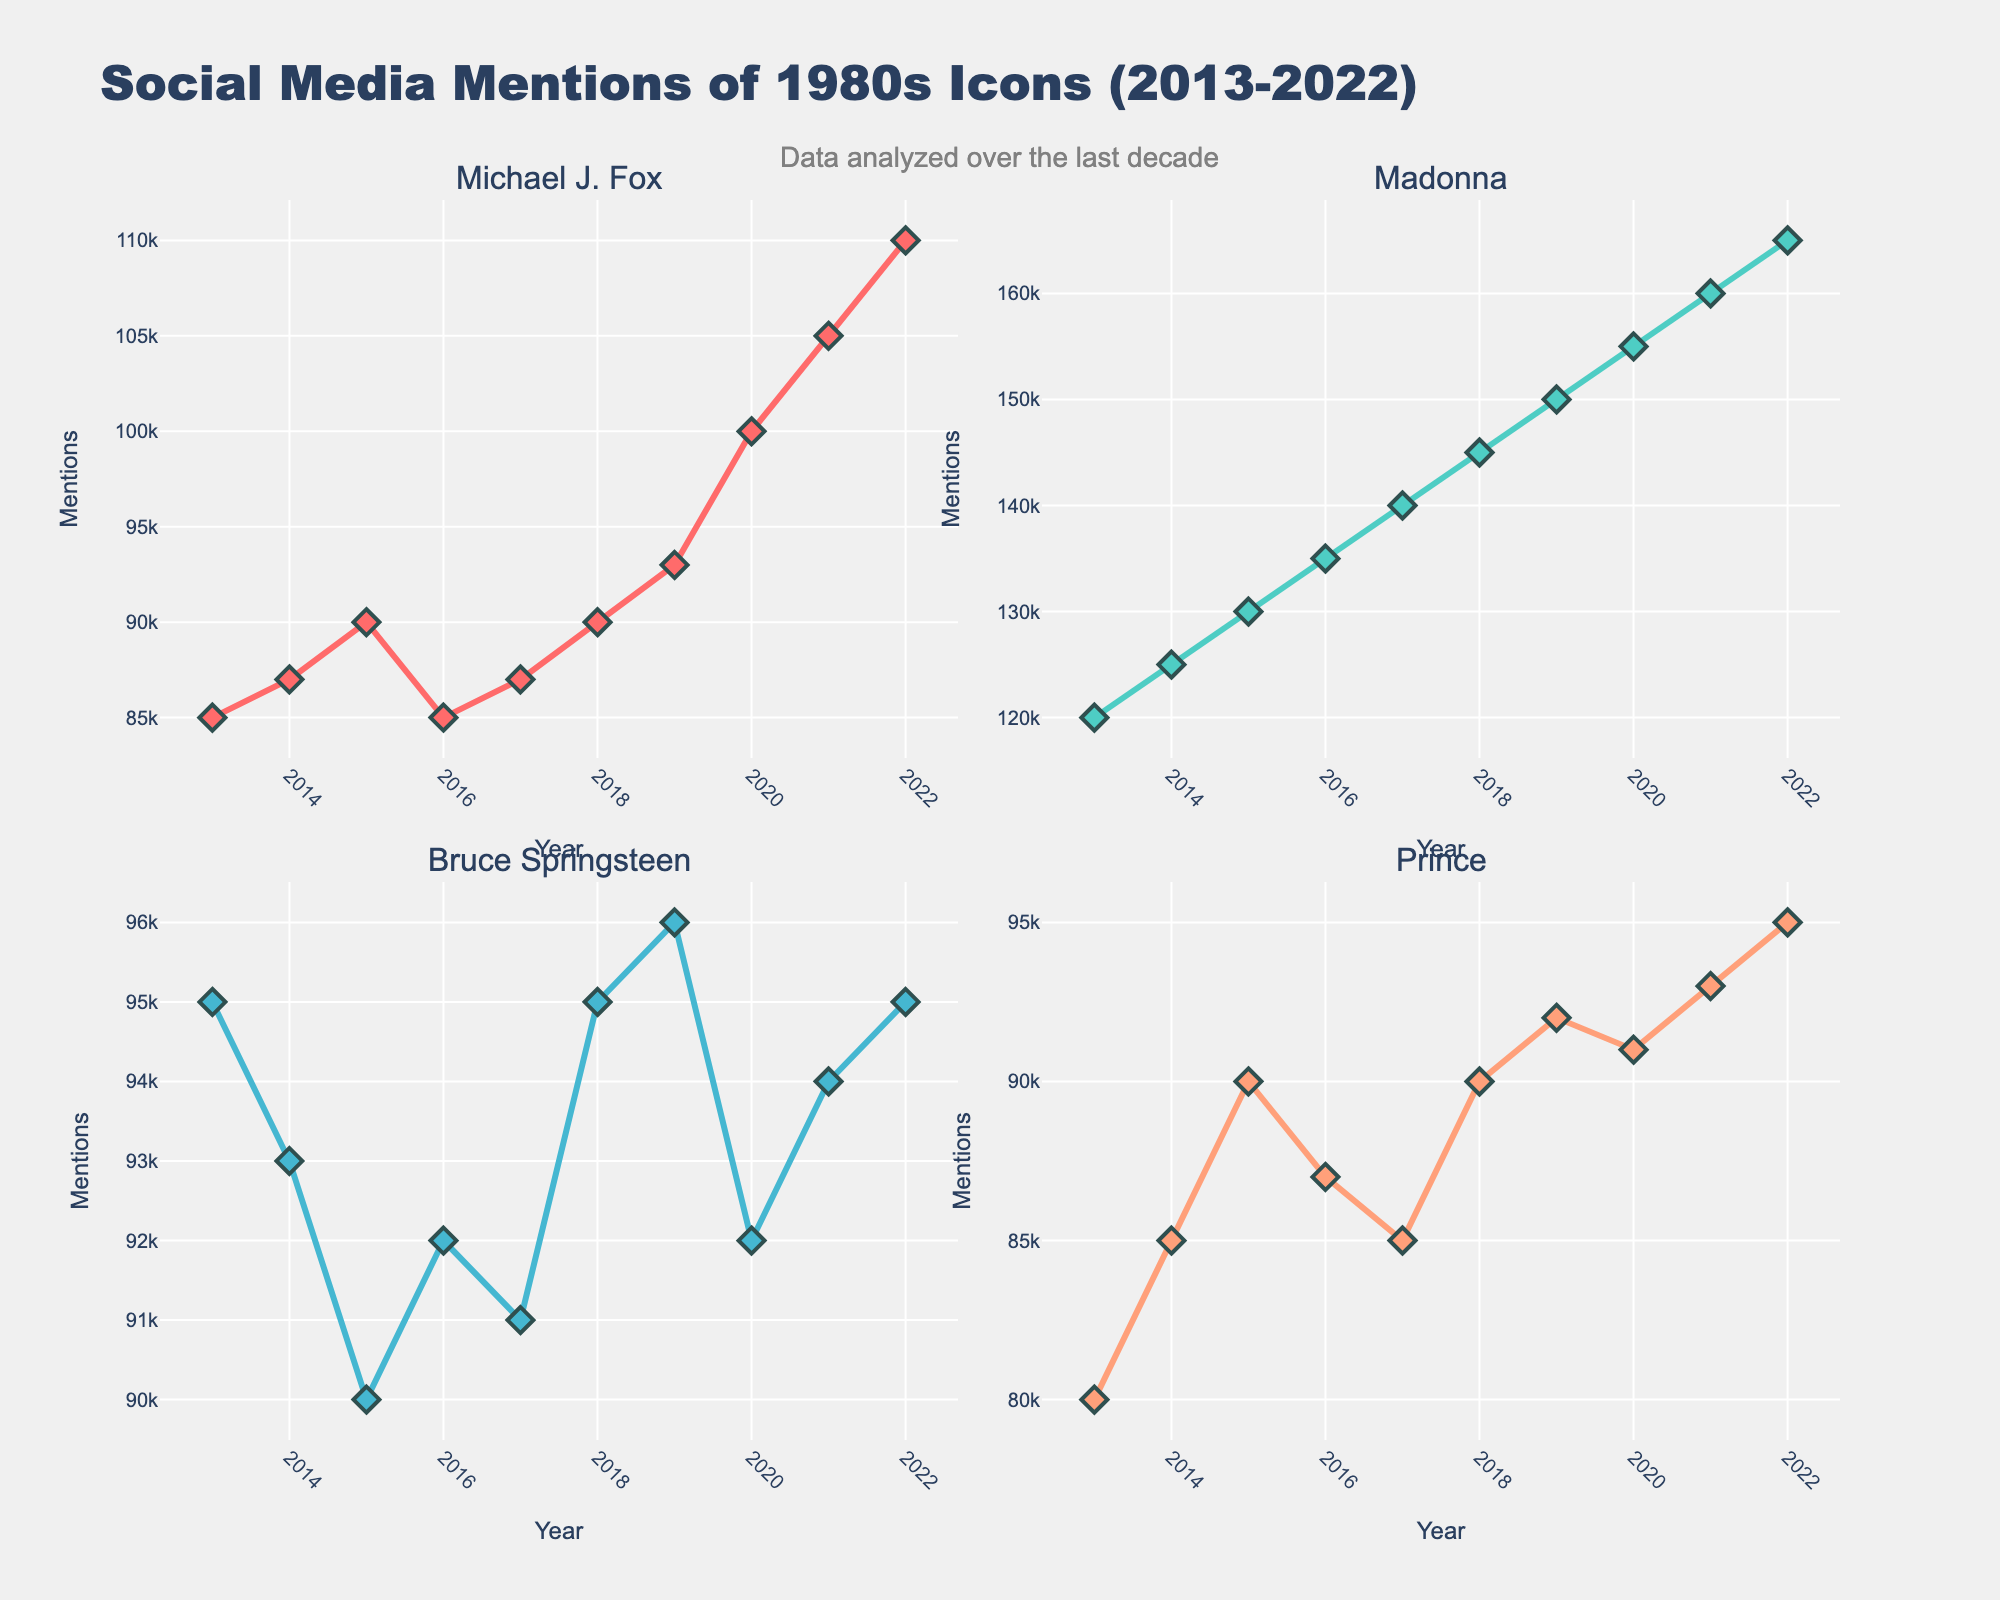What's the overall trend for Michael J. Fox's mentions from 2013 to 2022? To determine the trend, look at the line plot for Michael J. Fox. The number of mentions starts at 85,000 in 2013 and increases all the way to 110,000 in 2022. The line consistently goes upward over the years.
Answer: Increasing How do Madonna's social media mentions in 2018 compare to those in 2013? Look at Madonna's sub-plot and compare the 2018 and 2013 data points. In 2013, Madonna had 120,000 mentions. In 2018, the mentions increased to 145,000.
Answer: Increased Which year had the highest mentions for Prince? Examine Prince's sub-plot for the year with the highest data point. The mentions are highest in 2022, with 95,000 mentions.
Answer: 2022 Did Eddie Murphy's mentions ever reach 100,000? Look at Eddie Murphy’s plot across all years. The highest value visible is 96,000 in 2022, which is less than 100,000.
Answer: No Which icon had the least increase in mentions over the decade? To find this, calculate the increase for each icon. Michael J. Fox: 110,000 - 85,000 = 25,000. Madonna: 165,000 - 120,000 = 45,000. Bruce Springsteen: 95,000 - 95,000 = 0. Prince: 95,000 - 80,000 = 15,000. Eddie Murphy: 96,000 - 87,000 = 9,000.
Answer: Bruce Springsteen How do the 2020 mentions for Bruce Springsteen compare with those for Michael J. Fox in the same year? Look at the 2020 data points for both icons. For Michael J. Fox, it’s 100,000; for Bruce Springsteen, it's 92,000. Compare the two values.
Answer: Michael J. Fox had more mentions What's the average number of mentions for Madonna from 2013 to 2022? Sum the values and divide by the number of years. (120,000 + 125,000 + 130,000 + 135,000 + 140,000 + 145,000 + 150,000 + 155,000 + 160,000 + 165,000) / 10 = 142,500
Answer: 142,500 In which year did Eddie Murphy experience the smallest change in mentions compared to the previous year? Calculate the year-to-year changes: between 2013 and 2014 (-1,000), 2014 and 2015 (2,000), 2015 and 2016 (-1,000), 2016 and 2017 (1,000), 2017 and 2018 (2,000). The smallest change is between 2013-2014 or 2015-2016 or 2016-2017, all with 1,000 change.
Answer: 2013-2014 or 2015-2016 or 2016-2017 What's the difference between Madonna's mentions and the average mentions across all icons in 2022? Calculate the average mentions for all the icons in 2022: (110,000 + 165,000 + 95,000 + 95,000 + 96,000) / 5 = 112,200. The difference for Madonna: 165,000 - 112,200 = 52,800.
Answer: 52,800 